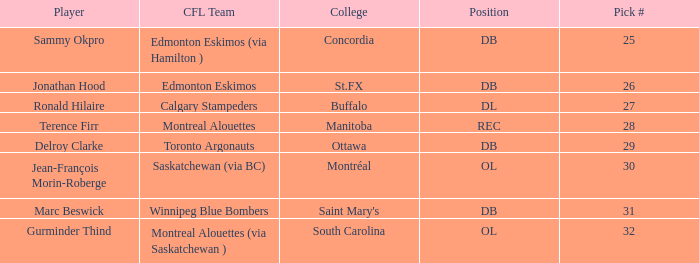Which pick # possesses a concordia college? 25.0. 